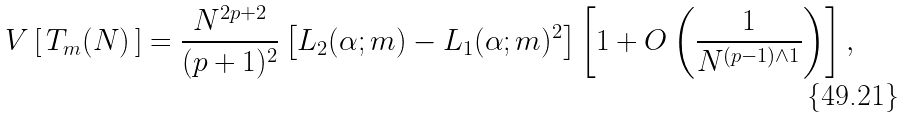Convert formula to latex. <formula><loc_0><loc_0><loc_500><loc_500>V \left [ \, T _ { m } ( N ) \, \right ] = \frac { N ^ { 2 p + 2 } } { ( p + 1 ) ^ { 2 } } \left [ L _ { 2 } ( \alpha ; m ) - L _ { 1 } ( \alpha ; m ) ^ { 2 } \right ] \left [ 1 + O \left ( \frac { 1 } { N ^ { ( p - 1 ) \wedge 1 } } \right ) \right ] ,</formula> 